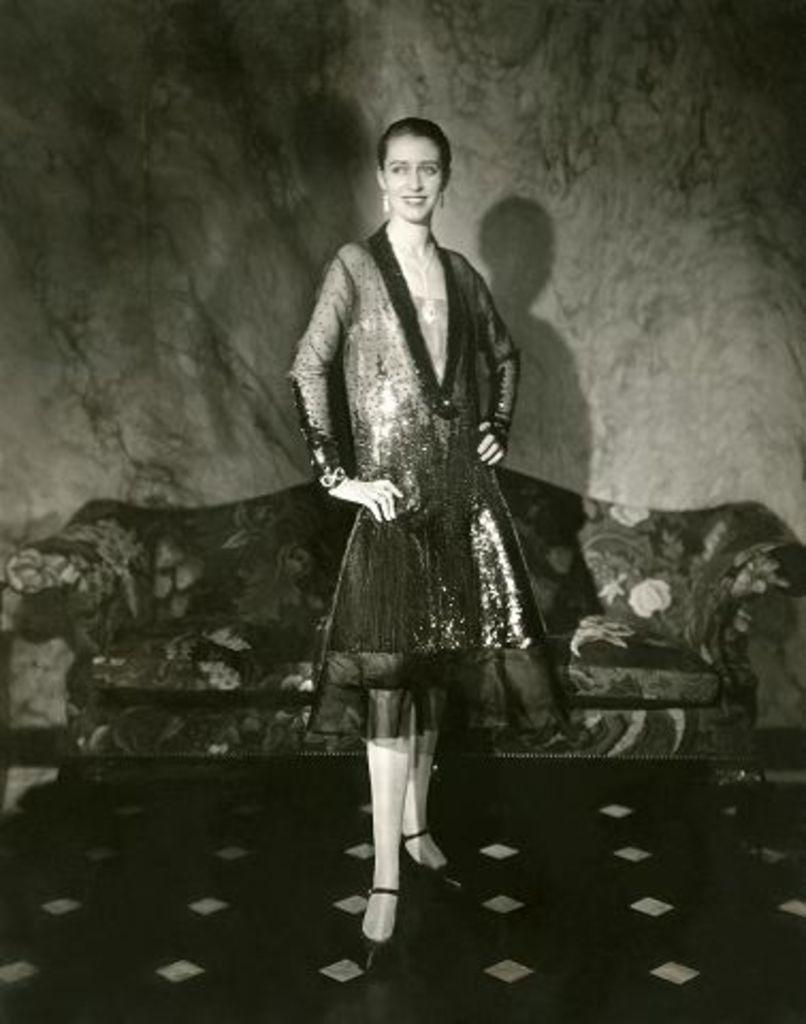What is the color scheme of the image? The image is black and white. Who or what is the main subject in the image? There is a girl standing in the image. Where is the girl standing? The girl is standing on the floor. What can be seen in the background of the image? There is a sofa and a wall in the background of the image. What type of car is parked in front of the wall in the image? There is no car present in the image; it only features a girl standing on the floor, a sofa, and a wall in the background. 